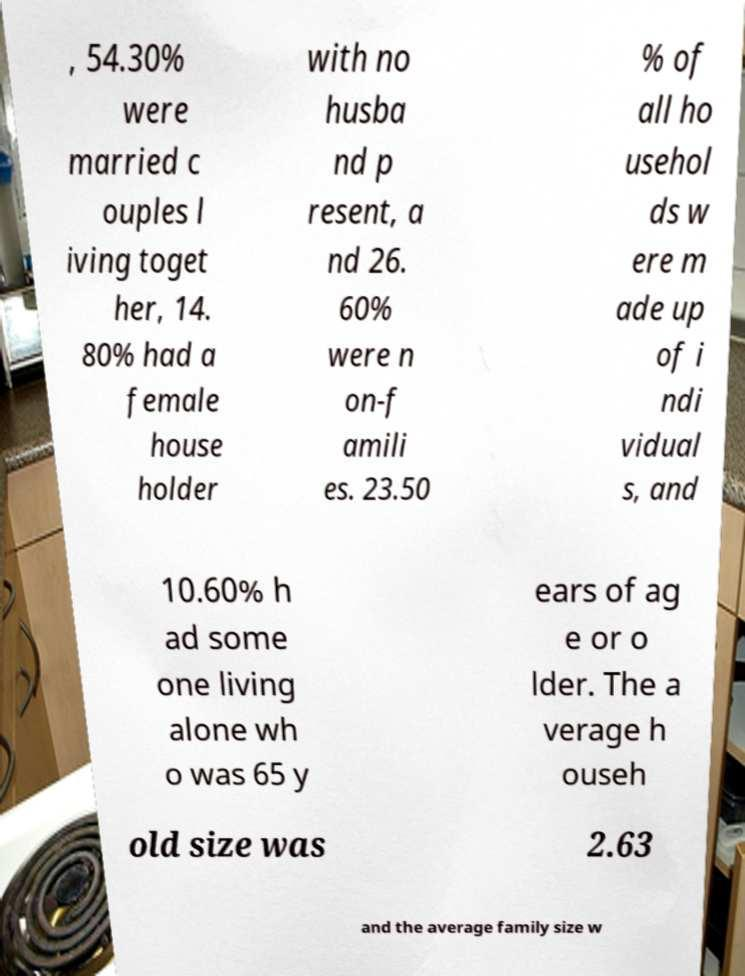Please identify and transcribe the text found in this image. , 54.30% were married c ouples l iving toget her, 14. 80% had a female house holder with no husba nd p resent, a nd 26. 60% were n on-f amili es. 23.50 % of all ho usehol ds w ere m ade up of i ndi vidual s, and 10.60% h ad some one living alone wh o was 65 y ears of ag e or o lder. The a verage h ouseh old size was 2.63 and the average family size w 